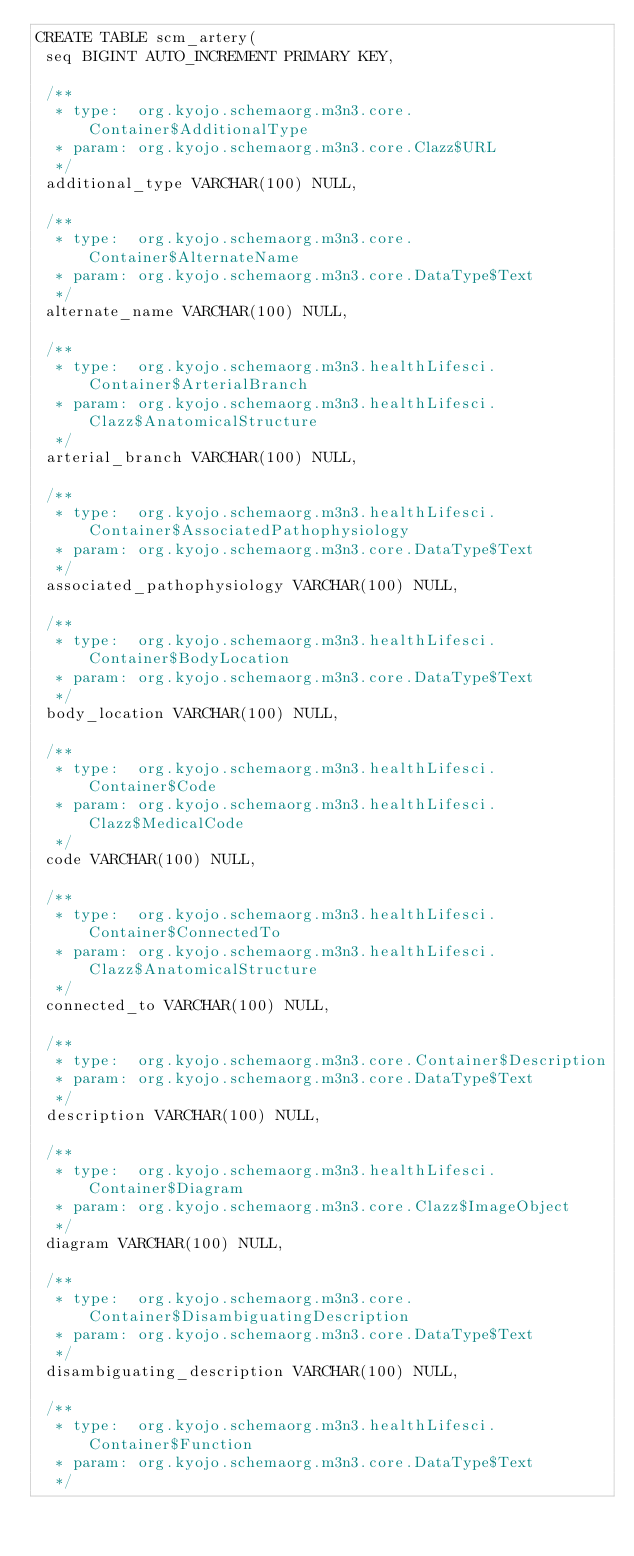<code> <loc_0><loc_0><loc_500><loc_500><_SQL_>CREATE TABLE scm_artery(
 seq BIGINT AUTO_INCREMENT PRIMARY KEY,

 /**
  * type:  org.kyojo.schemaorg.m3n3.core.Container$AdditionalType
  * param: org.kyojo.schemaorg.m3n3.core.Clazz$URL
  */
 additional_type VARCHAR(100) NULL,

 /**
  * type:  org.kyojo.schemaorg.m3n3.core.Container$AlternateName
  * param: org.kyojo.schemaorg.m3n3.core.DataType$Text
  */
 alternate_name VARCHAR(100) NULL,

 /**
  * type:  org.kyojo.schemaorg.m3n3.healthLifesci.Container$ArterialBranch
  * param: org.kyojo.schemaorg.m3n3.healthLifesci.Clazz$AnatomicalStructure
  */
 arterial_branch VARCHAR(100) NULL,

 /**
  * type:  org.kyojo.schemaorg.m3n3.healthLifesci.Container$AssociatedPathophysiology
  * param: org.kyojo.schemaorg.m3n3.core.DataType$Text
  */
 associated_pathophysiology VARCHAR(100) NULL,

 /**
  * type:  org.kyojo.schemaorg.m3n3.healthLifesci.Container$BodyLocation
  * param: org.kyojo.schemaorg.m3n3.core.DataType$Text
  */
 body_location VARCHAR(100) NULL,

 /**
  * type:  org.kyojo.schemaorg.m3n3.healthLifesci.Container$Code
  * param: org.kyojo.schemaorg.m3n3.healthLifesci.Clazz$MedicalCode
  */
 code VARCHAR(100) NULL,

 /**
  * type:  org.kyojo.schemaorg.m3n3.healthLifesci.Container$ConnectedTo
  * param: org.kyojo.schemaorg.m3n3.healthLifesci.Clazz$AnatomicalStructure
  */
 connected_to VARCHAR(100) NULL,

 /**
  * type:  org.kyojo.schemaorg.m3n3.core.Container$Description
  * param: org.kyojo.schemaorg.m3n3.core.DataType$Text
  */
 description VARCHAR(100) NULL,

 /**
  * type:  org.kyojo.schemaorg.m3n3.healthLifesci.Container$Diagram
  * param: org.kyojo.schemaorg.m3n3.core.Clazz$ImageObject
  */
 diagram VARCHAR(100) NULL,

 /**
  * type:  org.kyojo.schemaorg.m3n3.core.Container$DisambiguatingDescription
  * param: org.kyojo.schemaorg.m3n3.core.DataType$Text
  */
 disambiguating_description VARCHAR(100) NULL,

 /**
  * type:  org.kyojo.schemaorg.m3n3.healthLifesci.Container$Function
  * param: org.kyojo.schemaorg.m3n3.core.DataType$Text
  */</code> 